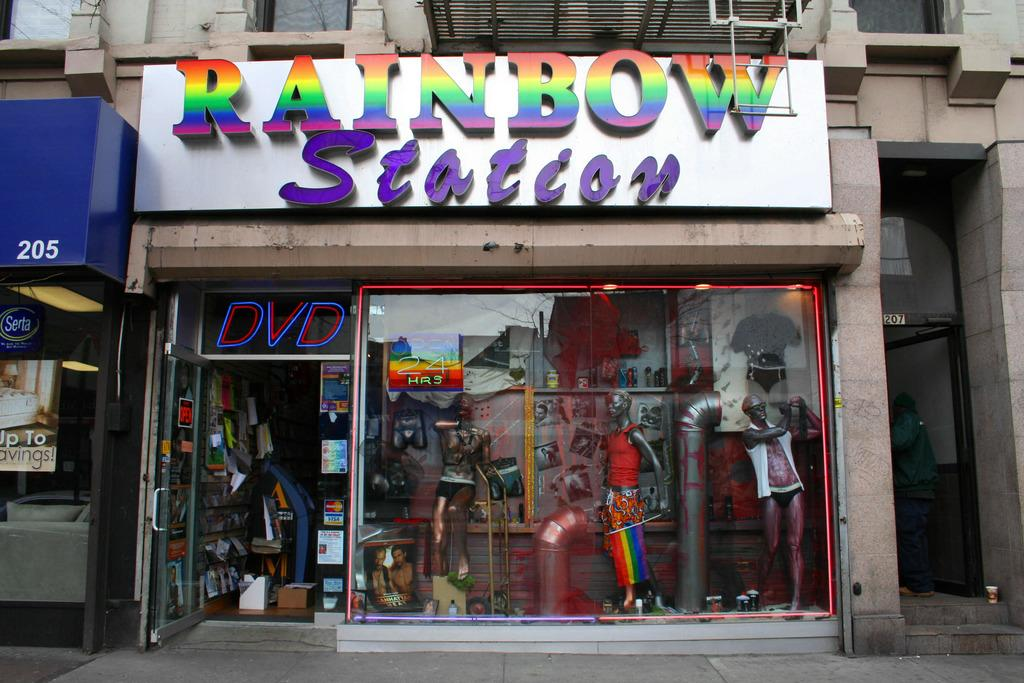<image>
Summarize the visual content of the image. Rainbow station that have dvd and the door open 